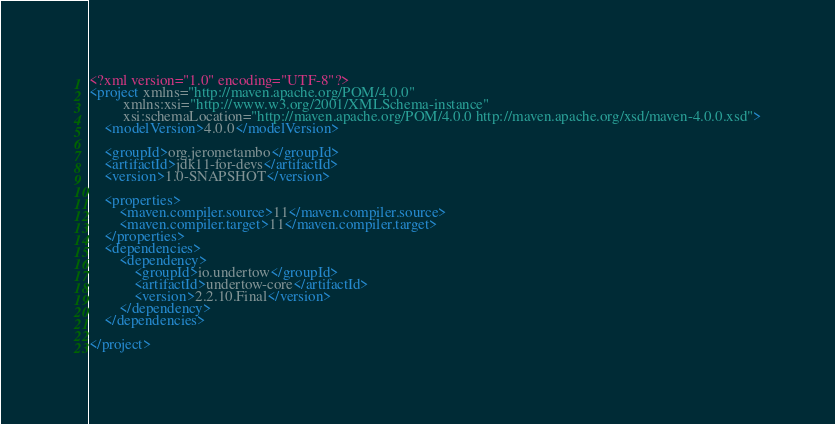<code> <loc_0><loc_0><loc_500><loc_500><_XML_><?xml version="1.0" encoding="UTF-8"?>
<project xmlns="http://maven.apache.org/POM/4.0.0"
         xmlns:xsi="http://www.w3.org/2001/XMLSchema-instance"
         xsi:schemaLocation="http://maven.apache.org/POM/4.0.0 http://maven.apache.org/xsd/maven-4.0.0.xsd">
    <modelVersion>4.0.0</modelVersion>

    <groupId>org.jerometambo</groupId>
    <artifactId>jdk11-for-devs</artifactId>
    <version>1.0-SNAPSHOT</version>

    <properties>
        <maven.compiler.source>11</maven.compiler.source>
        <maven.compiler.target>11</maven.compiler.target>
    </properties>
    <dependencies>
        <dependency>
            <groupId>io.undertow</groupId>
            <artifactId>undertow-core</artifactId>
            <version>2.2.10.Final</version>
        </dependency>
    </dependencies>

</project></code> 